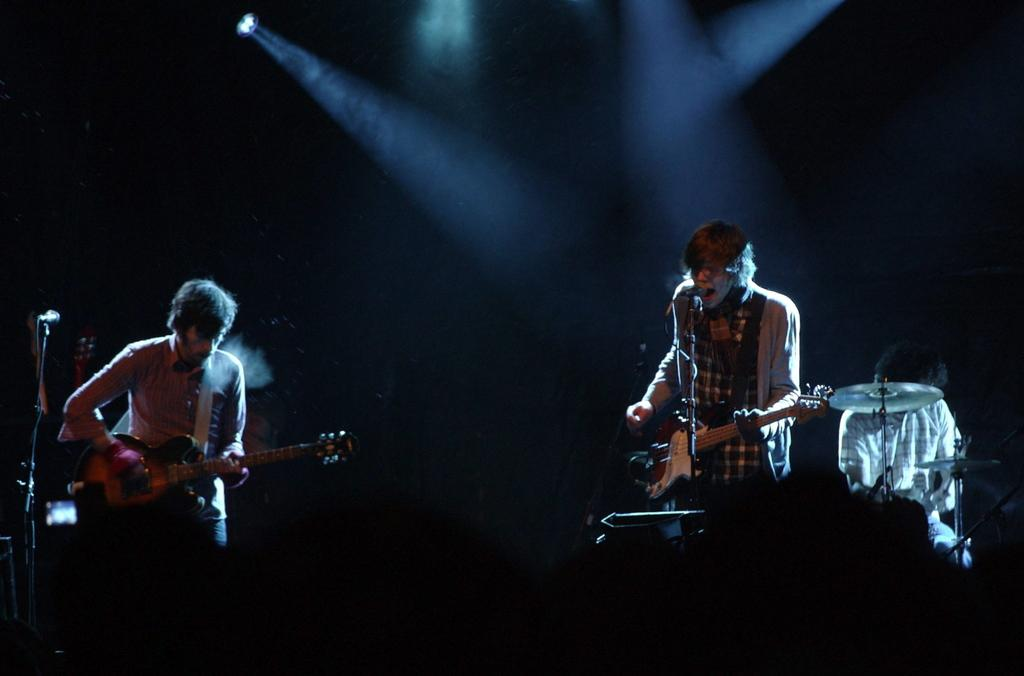What are the musicians doing in the image? The musicians are performing in the image. What objects are being used by the musicians? There are musical instruments in the image. What can be seen at the top of the image? There are lights visible at the top of the image. What type of mist is being used as a punishment for the musicians in the image? There is no mist or punishment present in the image; the musicians are performing with musical instruments. 